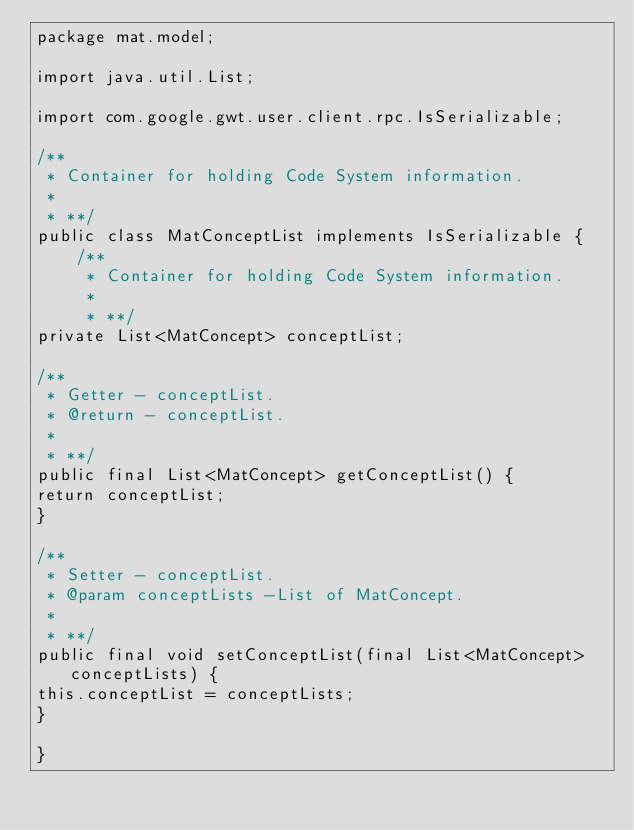Convert code to text. <code><loc_0><loc_0><loc_500><loc_500><_Java_>package mat.model;

import java.util.List;

import com.google.gwt.user.client.rpc.IsSerializable;

/**
 * Container for holding Code System information.
 *
 * **/
public class MatConceptList implements IsSerializable {
	/**
	 * Container for holding Code System information.
	 *
	 * **/
private List<MatConcept> conceptList;

/**
 * Getter - conceptList.
 * @return - conceptList.
 *
 * **/
public final List<MatConcept> getConceptList() {
return conceptList;
}

/**
 * Setter - conceptList.
 * @param conceptLists -List of MatConcept.
 *
 * **/
public final void setConceptList(final List<MatConcept> conceptLists) {
this.conceptList = conceptLists;
}

}
</code> 